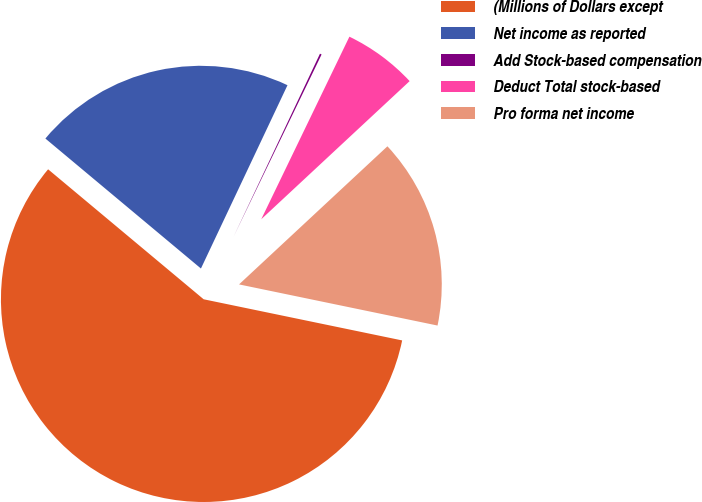Convert chart. <chart><loc_0><loc_0><loc_500><loc_500><pie_chart><fcel>(Millions of Dollars except<fcel>Net income as reported<fcel>Add Stock-based compensation<fcel>Deduct Total stock-based<fcel>Pro forma net income<nl><fcel>57.82%<fcel>20.94%<fcel>0.14%<fcel>5.91%<fcel>15.18%<nl></chart> 